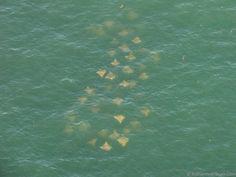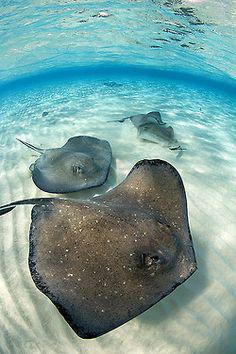The first image is the image on the left, the second image is the image on the right. Analyze the images presented: Is the assertion "There are at most 4 sting rays in one of the images." valid? Answer yes or no. Yes. 